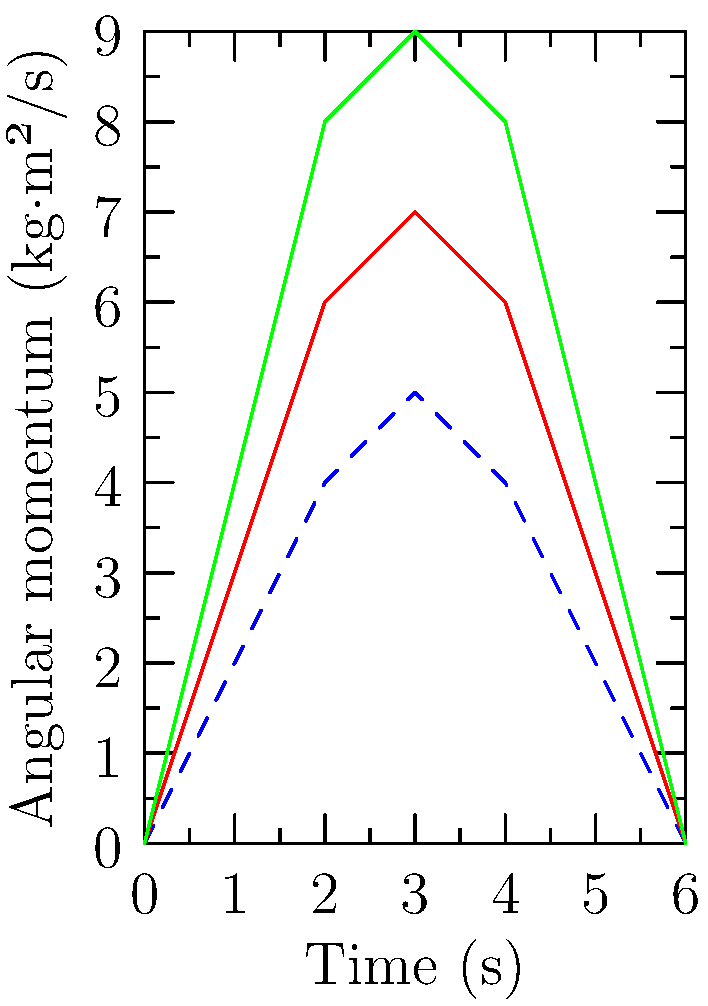Based on the diagram showing the angular momentum of a pitcher's arm during various pitching motions, which illegal pitch demonstrates the highest peak angular momentum, and by what percentage does it exceed the legal pitch's maximum? To solve this problem, we need to follow these steps:

1. Identify the maximum angular momentum for each pitch:
   - Legal pitch (blue dashed line): 5 kg·m²/s
   - Illegal pitch 1 (red line): 7 kg·m²/s
   - Illegal pitch 2 (green line): 9 kg·m²/s

2. Determine which illegal pitch has the highest peak:
   Illegal pitch 2 (green line) has the highest peak at 9 kg·m²/s.

3. Calculate the percentage difference between the highest illegal pitch and the legal pitch:
   - Difference = Illegal pitch 2 max - Legal pitch max
   - Difference = 9 - 5 = 4 kg·m²/s

4. Calculate the percentage:
   $$ \text{Percentage increase} = \frac{\text{Difference}}{\text{Legal pitch max}} \times 100\% $$
   $$ = \frac{4}{5} \times 100\% = 80\% $$

Therefore, illegal pitch 2 demonstrates the highest peak angular momentum, exceeding the legal pitch's maximum by 80%.
Answer: Illegal pitch 2, 80% 